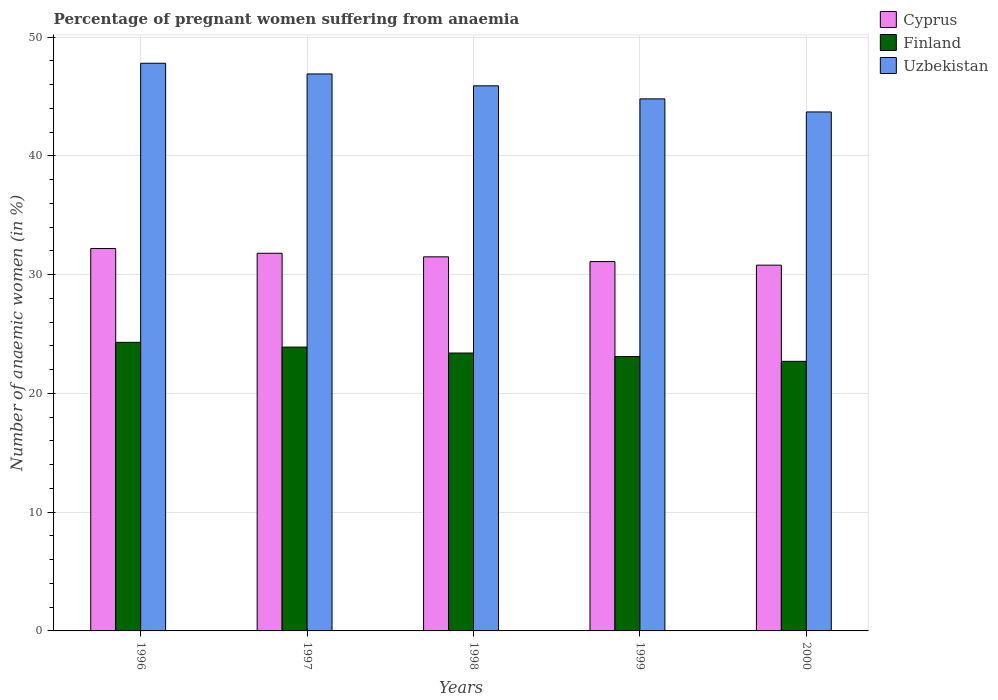How many different coloured bars are there?
Give a very brief answer. 3. Are the number of bars per tick equal to the number of legend labels?
Keep it short and to the point. Yes. Are the number of bars on each tick of the X-axis equal?
Provide a short and direct response. Yes. How many bars are there on the 3rd tick from the left?
Provide a short and direct response. 3. How many bars are there on the 1st tick from the right?
Your response must be concise. 3. In how many cases, is the number of bars for a given year not equal to the number of legend labels?
Provide a short and direct response. 0. What is the number of anaemic women in Cyprus in 1997?
Provide a short and direct response. 31.8. Across all years, what is the maximum number of anaemic women in Uzbekistan?
Give a very brief answer. 47.8. Across all years, what is the minimum number of anaemic women in Finland?
Ensure brevity in your answer.  22.7. In which year was the number of anaemic women in Uzbekistan maximum?
Your answer should be compact. 1996. What is the total number of anaemic women in Uzbekistan in the graph?
Ensure brevity in your answer.  229.1. What is the difference between the number of anaemic women in Cyprus in 1996 and that in 1998?
Offer a very short reply. 0.7. What is the difference between the number of anaemic women in Finland in 1996 and the number of anaemic women in Uzbekistan in 1999?
Provide a succinct answer. -20.5. What is the average number of anaemic women in Finland per year?
Offer a terse response. 23.48. In the year 2000, what is the difference between the number of anaemic women in Finland and number of anaemic women in Cyprus?
Offer a terse response. -8.1. In how many years, is the number of anaemic women in Finland greater than 4 %?
Your answer should be very brief. 5. What is the ratio of the number of anaemic women in Cyprus in 1998 to that in 1999?
Your answer should be compact. 1.01. Is the difference between the number of anaemic women in Finland in 1996 and 1998 greater than the difference between the number of anaemic women in Cyprus in 1996 and 1998?
Keep it short and to the point. Yes. What is the difference between the highest and the second highest number of anaemic women in Finland?
Your answer should be compact. 0.4. What is the difference between the highest and the lowest number of anaemic women in Finland?
Provide a short and direct response. 1.6. Is the sum of the number of anaemic women in Cyprus in 1997 and 1998 greater than the maximum number of anaemic women in Finland across all years?
Your answer should be compact. Yes. What does the 3rd bar from the left in 1999 represents?
Offer a terse response. Uzbekistan. Is it the case that in every year, the sum of the number of anaemic women in Uzbekistan and number of anaemic women in Finland is greater than the number of anaemic women in Cyprus?
Your response must be concise. Yes. How many years are there in the graph?
Ensure brevity in your answer.  5. Are the values on the major ticks of Y-axis written in scientific E-notation?
Make the answer very short. No. How are the legend labels stacked?
Give a very brief answer. Vertical. What is the title of the graph?
Provide a succinct answer. Percentage of pregnant women suffering from anaemia. What is the label or title of the X-axis?
Your response must be concise. Years. What is the label or title of the Y-axis?
Your answer should be compact. Number of anaemic women (in %). What is the Number of anaemic women (in %) in Cyprus in 1996?
Keep it short and to the point. 32.2. What is the Number of anaemic women (in %) of Finland in 1996?
Give a very brief answer. 24.3. What is the Number of anaemic women (in %) of Uzbekistan in 1996?
Your response must be concise. 47.8. What is the Number of anaemic women (in %) in Cyprus in 1997?
Make the answer very short. 31.8. What is the Number of anaemic women (in %) of Finland in 1997?
Your answer should be compact. 23.9. What is the Number of anaemic women (in %) in Uzbekistan in 1997?
Offer a terse response. 46.9. What is the Number of anaemic women (in %) in Cyprus in 1998?
Ensure brevity in your answer.  31.5. What is the Number of anaemic women (in %) of Finland in 1998?
Ensure brevity in your answer.  23.4. What is the Number of anaemic women (in %) of Uzbekistan in 1998?
Your answer should be compact. 45.9. What is the Number of anaemic women (in %) in Cyprus in 1999?
Keep it short and to the point. 31.1. What is the Number of anaemic women (in %) of Finland in 1999?
Your answer should be very brief. 23.1. What is the Number of anaemic women (in %) of Uzbekistan in 1999?
Keep it short and to the point. 44.8. What is the Number of anaemic women (in %) of Cyprus in 2000?
Ensure brevity in your answer.  30.8. What is the Number of anaemic women (in %) of Finland in 2000?
Provide a short and direct response. 22.7. What is the Number of anaemic women (in %) in Uzbekistan in 2000?
Your answer should be very brief. 43.7. Across all years, what is the maximum Number of anaemic women (in %) in Cyprus?
Provide a short and direct response. 32.2. Across all years, what is the maximum Number of anaemic women (in %) of Finland?
Offer a very short reply. 24.3. Across all years, what is the maximum Number of anaemic women (in %) of Uzbekistan?
Keep it short and to the point. 47.8. Across all years, what is the minimum Number of anaemic women (in %) in Cyprus?
Offer a terse response. 30.8. Across all years, what is the minimum Number of anaemic women (in %) in Finland?
Make the answer very short. 22.7. Across all years, what is the minimum Number of anaemic women (in %) in Uzbekistan?
Your response must be concise. 43.7. What is the total Number of anaemic women (in %) of Cyprus in the graph?
Offer a very short reply. 157.4. What is the total Number of anaemic women (in %) in Finland in the graph?
Keep it short and to the point. 117.4. What is the total Number of anaemic women (in %) of Uzbekistan in the graph?
Keep it short and to the point. 229.1. What is the difference between the Number of anaemic women (in %) of Finland in 1996 and that in 1997?
Give a very brief answer. 0.4. What is the difference between the Number of anaemic women (in %) of Cyprus in 1996 and that in 1998?
Ensure brevity in your answer.  0.7. What is the difference between the Number of anaemic women (in %) in Cyprus in 1996 and that in 1999?
Make the answer very short. 1.1. What is the difference between the Number of anaemic women (in %) in Cyprus in 1996 and that in 2000?
Your answer should be compact. 1.4. What is the difference between the Number of anaemic women (in %) in Uzbekistan in 1996 and that in 2000?
Give a very brief answer. 4.1. What is the difference between the Number of anaemic women (in %) of Finland in 1997 and that in 1998?
Your response must be concise. 0.5. What is the difference between the Number of anaemic women (in %) in Uzbekistan in 1997 and that in 1998?
Provide a succinct answer. 1. What is the difference between the Number of anaemic women (in %) in Cyprus in 1997 and that in 1999?
Give a very brief answer. 0.7. What is the difference between the Number of anaemic women (in %) of Finland in 1997 and that in 1999?
Your answer should be very brief. 0.8. What is the difference between the Number of anaemic women (in %) in Finland in 1997 and that in 2000?
Offer a terse response. 1.2. What is the difference between the Number of anaemic women (in %) of Uzbekistan in 1997 and that in 2000?
Ensure brevity in your answer.  3.2. What is the difference between the Number of anaemic women (in %) in Finland in 1998 and that in 1999?
Offer a terse response. 0.3. What is the difference between the Number of anaemic women (in %) in Uzbekistan in 1998 and that in 1999?
Offer a terse response. 1.1. What is the difference between the Number of anaemic women (in %) of Uzbekistan in 1998 and that in 2000?
Give a very brief answer. 2.2. What is the difference between the Number of anaemic women (in %) in Cyprus in 1999 and that in 2000?
Provide a succinct answer. 0.3. What is the difference between the Number of anaemic women (in %) in Uzbekistan in 1999 and that in 2000?
Provide a short and direct response. 1.1. What is the difference between the Number of anaemic women (in %) in Cyprus in 1996 and the Number of anaemic women (in %) in Finland in 1997?
Your answer should be very brief. 8.3. What is the difference between the Number of anaemic women (in %) of Cyprus in 1996 and the Number of anaemic women (in %) of Uzbekistan in 1997?
Your response must be concise. -14.7. What is the difference between the Number of anaemic women (in %) of Finland in 1996 and the Number of anaemic women (in %) of Uzbekistan in 1997?
Keep it short and to the point. -22.6. What is the difference between the Number of anaemic women (in %) of Cyprus in 1996 and the Number of anaemic women (in %) of Finland in 1998?
Provide a short and direct response. 8.8. What is the difference between the Number of anaemic women (in %) of Cyprus in 1996 and the Number of anaemic women (in %) of Uzbekistan in 1998?
Provide a short and direct response. -13.7. What is the difference between the Number of anaemic women (in %) in Finland in 1996 and the Number of anaemic women (in %) in Uzbekistan in 1998?
Offer a terse response. -21.6. What is the difference between the Number of anaemic women (in %) in Cyprus in 1996 and the Number of anaemic women (in %) in Uzbekistan in 1999?
Your response must be concise. -12.6. What is the difference between the Number of anaemic women (in %) in Finland in 1996 and the Number of anaemic women (in %) in Uzbekistan in 1999?
Provide a succinct answer. -20.5. What is the difference between the Number of anaemic women (in %) of Finland in 1996 and the Number of anaemic women (in %) of Uzbekistan in 2000?
Your response must be concise. -19.4. What is the difference between the Number of anaemic women (in %) of Cyprus in 1997 and the Number of anaemic women (in %) of Uzbekistan in 1998?
Give a very brief answer. -14.1. What is the difference between the Number of anaemic women (in %) in Finland in 1997 and the Number of anaemic women (in %) in Uzbekistan in 1998?
Your response must be concise. -22. What is the difference between the Number of anaemic women (in %) of Finland in 1997 and the Number of anaemic women (in %) of Uzbekistan in 1999?
Keep it short and to the point. -20.9. What is the difference between the Number of anaemic women (in %) of Cyprus in 1997 and the Number of anaemic women (in %) of Finland in 2000?
Give a very brief answer. 9.1. What is the difference between the Number of anaemic women (in %) of Finland in 1997 and the Number of anaemic women (in %) of Uzbekistan in 2000?
Make the answer very short. -19.8. What is the difference between the Number of anaemic women (in %) of Cyprus in 1998 and the Number of anaemic women (in %) of Uzbekistan in 1999?
Provide a short and direct response. -13.3. What is the difference between the Number of anaemic women (in %) of Finland in 1998 and the Number of anaemic women (in %) of Uzbekistan in 1999?
Ensure brevity in your answer.  -21.4. What is the difference between the Number of anaemic women (in %) of Cyprus in 1998 and the Number of anaemic women (in %) of Uzbekistan in 2000?
Offer a terse response. -12.2. What is the difference between the Number of anaemic women (in %) of Finland in 1998 and the Number of anaemic women (in %) of Uzbekistan in 2000?
Provide a succinct answer. -20.3. What is the difference between the Number of anaemic women (in %) in Cyprus in 1999 and the Number of anaemic women (in %) in Uzbekistan in 2000?
Offer a terse response. -12.6. What is the difference between the Number of anaemic women (in %) of Finland in 1999 and the Number of anaemic women (in %) of Uzbekistan in 2000?
Your answer should be compact. -20.6. What is the average Number of anaemic women (in %) in Cyprus per year?
Offer a very short reply. 31.48. What is the average Number of anaemic women (in %) of Finland per year?
Your answer should be compact. 23.48. What is the average Number of anaemic women (in %) in Uzbekistan per year?
Ensure brevity in your answer.  45.82. In the year 1996, what is the difference between the Number of anaemic women (in %) in Cyprus and Number of anaemic women (in %) in Uzbekistan?
Give a very brief answer. -15.6. In the year 1996, what is the difference between the Number of anaemic women (in %) in Finland and Number of anaemic women (in %) in Uzbekistan?
Offer a very short reply. -23.5. In the year 1997, what is the difference between the Number of anaemic women (in %) of Cyprus and Number of anaemic women (in %) of Finland?
Offer a terse response. 7.9. In the year 1997, what is the difference between the Number of anaemic women (in %) in Cyprus and Number of anaemic women (in %) in Uzbekistan?
Provide a succinct answer. -15.1. In the year 1998, what is the difference between the Number of anaemic women (in %) in Cyprus and Number of anaemic women (in %) in Finland?
Give a very brief answer. 8.1. In the year 1998, what is the difference between the Number of anaemic women (in %) in Cyprus and Number of anaemic women (in %) in Uzbekistan?
Ensure brevity in your answer.  -14.4. In the year 1998, what is the difference between the Number of anaemic women (in %) in Finland and Number of anaemic women (in %) in Uzbekistan?
Ensure brevity in your answer.  -22.5. In the year 1999, what is the difference between the Number of anaemic women (in %) in Cyprus and Number of anaemic women (in %) in Finland?
Ensure brevity in your answer.  8. In the year 1999, what is the difference between the Number of anaemic women (in %) of Cyprus and Number of anaemic women (in %) of Uzbekistan?
Keep it short and to the point. -13.7. In the year 1999, what is the difference between the Number of anaemic women (in %) in Finland and Number of anaemic women (in %) in Uzbekistan?
Provide a succinct answer. -21.7. In the year 2000, what is the difference between the Number of anaemic women (in %) in Cyprus and Number of anaemic women (in %) in Uzbekistan?
Your answer should be compact. -12.9. In the year 2000, what is the difference between the Number of anaemic women (in %) in Finland and Number of anaemic women (in %) in Uzbekistan?
Your response must be concise. -21. What is the ratio of the Number of anaemic women (in %) in Cyprus in 1996 to that in 1997?
Give a very brief answer. 1.01. What is the ratio of the Number of anaemic women (in %) of Finland in 1996 to that in 1997?
Keep it short and to the point. 1.02. What is the ratio of the Number of anaemic women (in %) in Uzbekistan in 1996 to that in 1997?
Give a very brief answer. 1.02. What is the ratio of the Number of anaemic women (in %) in Cyprus in 1996 to that in 1998?
Your answer should be very brief. 1.02. What is the ratio of the Number of anaemic women (in %) of Uzbekistan in 1996 to that in 1998?
Offer a terse response. 1.04. What is the ratio of the Number of anaemic women (in %) of Cyprus in 1996 to that in 1999?
Your answer should be very brief. 1.04. What is the ratio of the Number of anaemic women (in %) in Finland in 1996 to that in 1999?
Make the answer very short. 1.05. What is the ratio of the Number of anaemic women (in %) of Uzbekistan in 1996 to that in 1999?
Your response must be concise. 1.07. What is the ratio of the Number of anaemic women (in %) in Cyprus in 1996 to that in 2000?
Provide a succinct answer. 1.05. What is the ratio of the Number of anaemic women (in %) in Finland in 1996 to that in 2000?
Make the answer very short. 1.07. What is the ratio of the Number of anaemic women (in %) in Uzbekistan in 1996 to that in 2000?
Offer a terse response. 1.09. What is the ratio of the Number of anaemic women (in %) in Cyprus in 1997 to that in 1998?
Ensure brevity in your answer.  1.01. What is the ratio of the Number of anaemic women (in %) of Finland in 1997 to that in 1998?
Offer a very short reply. 1.02. What is the ratio of the Number of anaemic women (in %) in Uzbekistan in 1997 to that in 1998?
Ensure brevity in your answer.  1.02. What is the ratio of the Number of anaemic women (in %) of Cyprus in 1997 to that in 1999?
Your response must be concise. 1.02. What is the ratio of the Number of anaemic women (in %) of Finland in 1997 to that in 1999?
Offer a terse response. 1.03. What is the ratio of the Number of anaemic women (in %) of Uzbekistan in 1997 to that in 1999?
Provide a short and direct response. 1.05. What is the ratio of the Number of anaemic women (in %) of Cyprus in 1997 to that in 2000?
Give a very brief answer. 1.03. What is the ratio of the Number of anaemic women (in %) in Finland in 1997 to that in 2000?
Give a very brief answer. 1.05. What is the ratio of the Number of anaemic women (in %) in Uzbekistan in 1997 to that in 2000?
Make the answer very short. 1.07. What is the ratio of the Number of anaemic women (in %) in Cyprus in 1998 to that in 1999?
Make the answer very short. 1.01. What is the ratio of the Number of anaemic women (in %) in Finland in 1998 to that in 1999?
Provide a short and direct response. 1.01. What is the ratio of the Number of anaemic women (in %) in Uzbekistan in 1998 to that in 1999?
Your response must be concise. 1.02. What is the ratio of the Number of anaemic women (in %) in Cyprus in 1998 to that in 2000?
Keep it short and to the point. 1.02. What is the ratio of the Number of anaemic women (in %) in Finland in 1998 to that in 2000?
Offer a very short reply. 1.03. What is the ratio of the Number of anaemic women (in %) of Uzbekistan in 1998 to that in 2000?
Offer a terse response. 1.05. What is the ratio of the Number of anaemic women (in %) of Cyprus in 1999 to that in 2000?
Make the answer very short. 1.01. What is the ratio of the Number of anaemic women (in %) of Finland in 1999 to that in 2000?
Make the answer very short. 1.02. What is the ratio of the Number of anaemic women (in %) in Uzbekistan in 1999 to that in 2000?
Make the answer very short. 1.03. What is the difference between the highest and the second highest Number of anaemic women (in %) of Finland?
Provide a succinct answer. 0.4. 